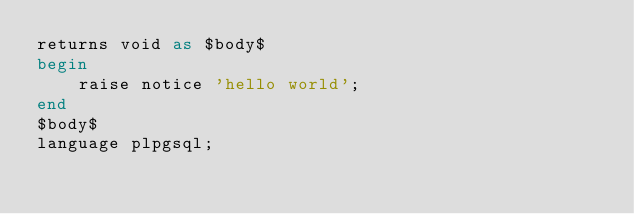Convert code to text. <code><loc_0><loc_0><loc_500><loc_500><_SQL_>returns void as $body$
begin
    raise notice 'hello world';
end
$body$
language plpgsql;</code> 